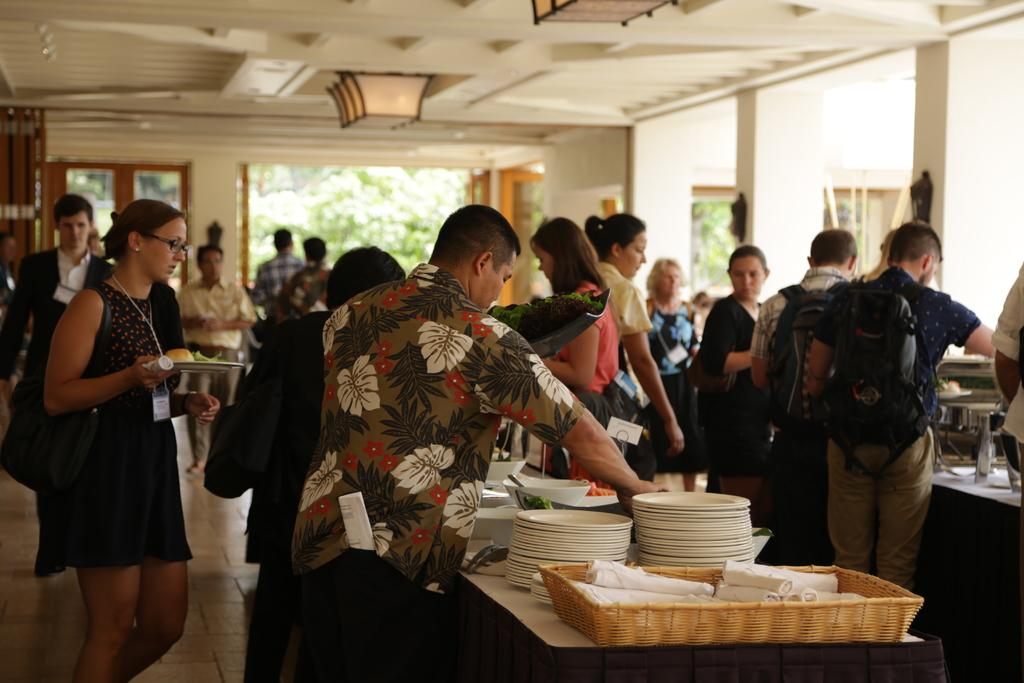How many people are in the image? There are people in the image, but the exact number is not specified. What are the people doing in the image? The people are standing and serving food. What objects can be seen related to serving food? There are plates in the image. What is present on the table in the image? There is food on the table. What type of pancake is being compared to the food on the table? There is no pancake present in the image, nor is there any comparison being made. 